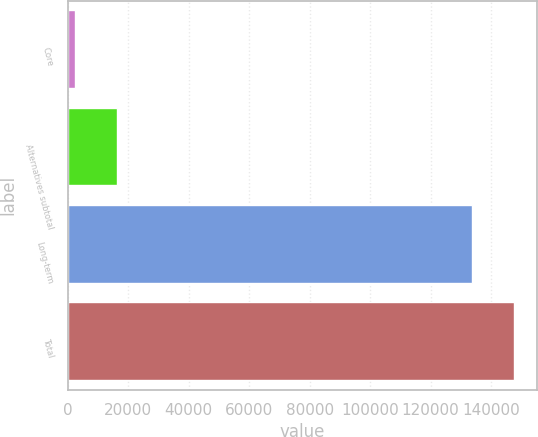Convert chart to OTSL. <chart><loc_0><loc_0><loc_500><loc_500><bar_chart><fcel>Core<fcel>Alternatives subtotal<fcel>Long-term<fcel>Total<nl><fcel>2421<fcel>16271.3<fcel>133874<fcel>147724<nl></chart> 